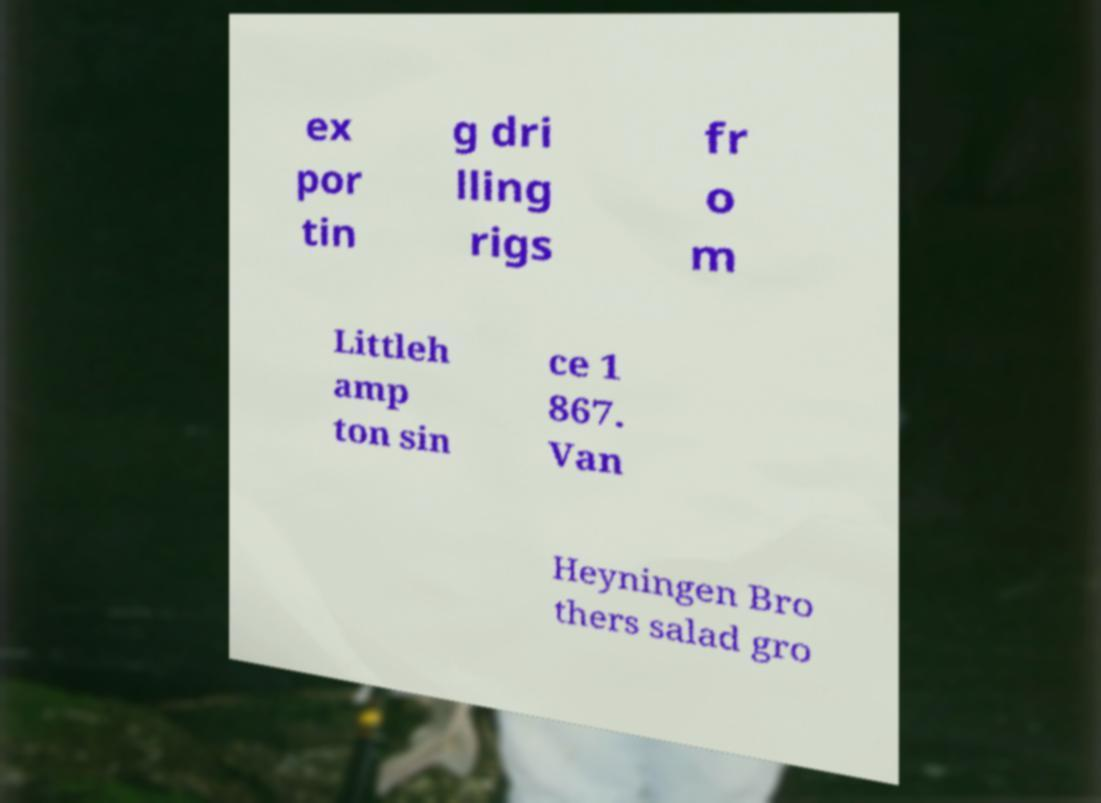There's text embedded in this image that I need extracted. Can you transcribe it verbatim? ex por tin g dri lling rigs fr o m Littleh amp ton sin ce 1 867. Van Heyningen Bro thers salad gro 